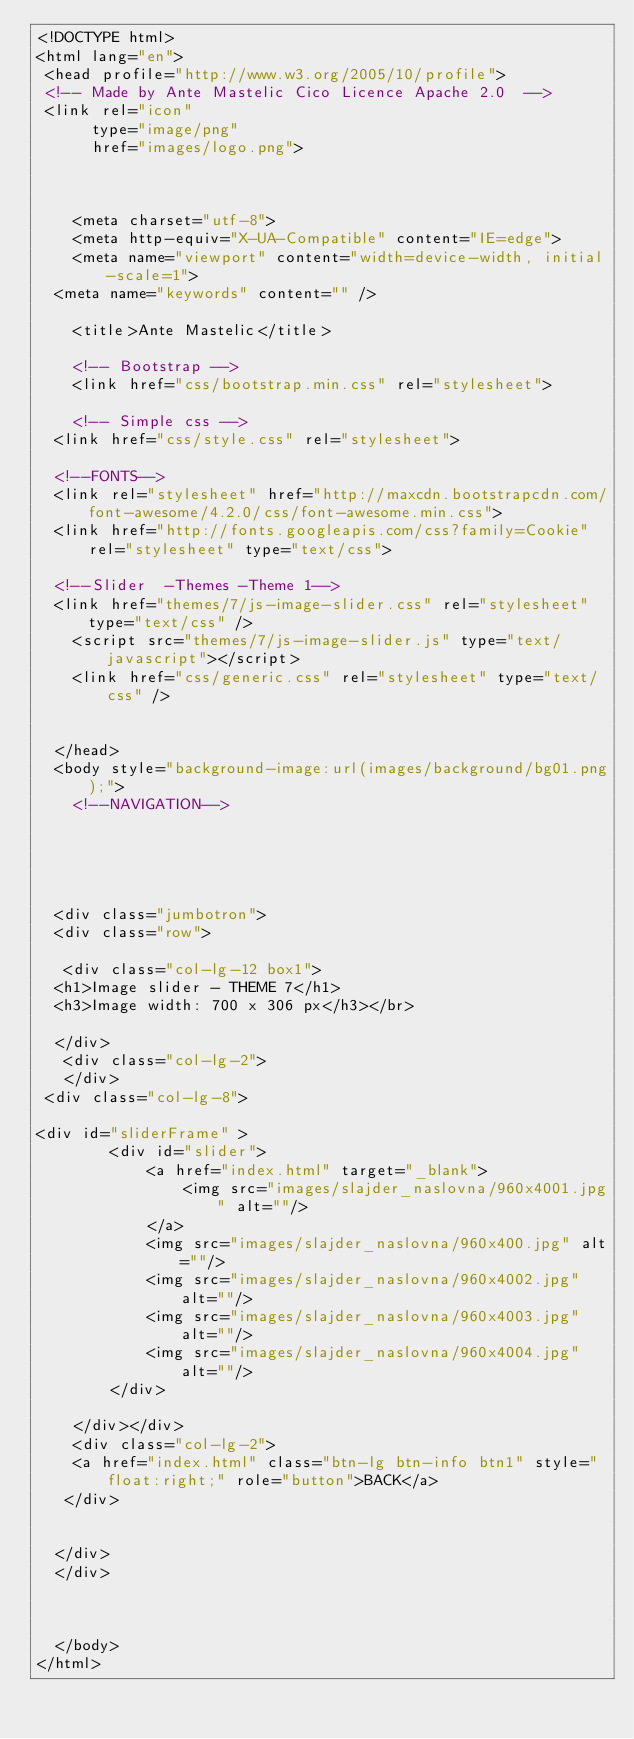<code> <loc_0><loc_0><loc_500><loc_500><_HTML_><!DOCTYPE html>
<html lang="en">
 <head profile="http://www.w3.org/2005/10/profile">
 <!-- Made by Ante Mastelic Cico Licence Apache 2.0  -->
 <link rel="icon" 
      type="image/png" 
      href="images/logo.png">
 
 
 
    <meta charset="utf-8">
    <meta http-equiv="X-UA-Compatible" content="IE=edge">
    <meta name="viewport" content="width=device-width, initial-scale=1">
	<meta name="keywords" content="" />
    
    <title>Ante Mastelic</title>

    <!-- Bootstrap -->
    <link href="css/bootstrap.min.css" rel="stylesheet">
	
    <!-- Simple css -->
	<link href="css/style.css" rel="stylesheet">
	
	<!--FONTS-->
	<link rel="stylesheet" href="http://maxcdn.bootstrapcdn.com/font-awesome/4.2.0/css/font-awesome.min.css">
	<link href="http://fonts.googleapis.com/css?family=Cookie" rel="stylesheet" type="text/css">
	
	<!--Slider  -Themes -Theme 1-->
	<link href="themes/7/js-image-slider.css" rel="stylesheet" type="text/css" />
    <script src="themes/7/js-image-slider.js" type="text/javascript"></script>
    <link href="css/generic.css" rel="stylesheet" type="text/css" />
	

  </head>
  <body style="background-image:url(images/background/bg01.png);">
		<!--NAVIGATION-->

  

 

  <div class="jumbotron">
  <div class="row">
   
   <div class="col-lg-12 box1">
	<h1>Image slider - THEME 7</h1>
	<h3>Image width: 700 x 306 px</h3></br>

	</div>
   <div class="col-lg-2">
   </div>
 <div class="col-lg-8">
	
<div id="sliderFrame" >
        <div id="slider">
            <a href="index.html" target="_blank">
                <img src="images/slajder_naslovna/960x4001.jpg" alt=""/>
            </a>
            <img src="images/slajder_naslovna/960x400.jpg" alt=""/>
            <img src="images/slajder_naslovna/960x4002.jpg" alt=""/>
            <img src="images/slajder_naslovna/960x4003.jpg" alt=""/>
            <img src="images/slajder_naslovna/960x4004.jpg"  alt=""/>
        </div>
       
    </div></div>
	  <div class="col-lg-2">
	  <a href="index.html" class="btn-lg btn-info btn1" style="float:right;" role="button">BACK</a>
   </div>


	</div>
	</div>
	
	
	
  </body>
</html></code> 